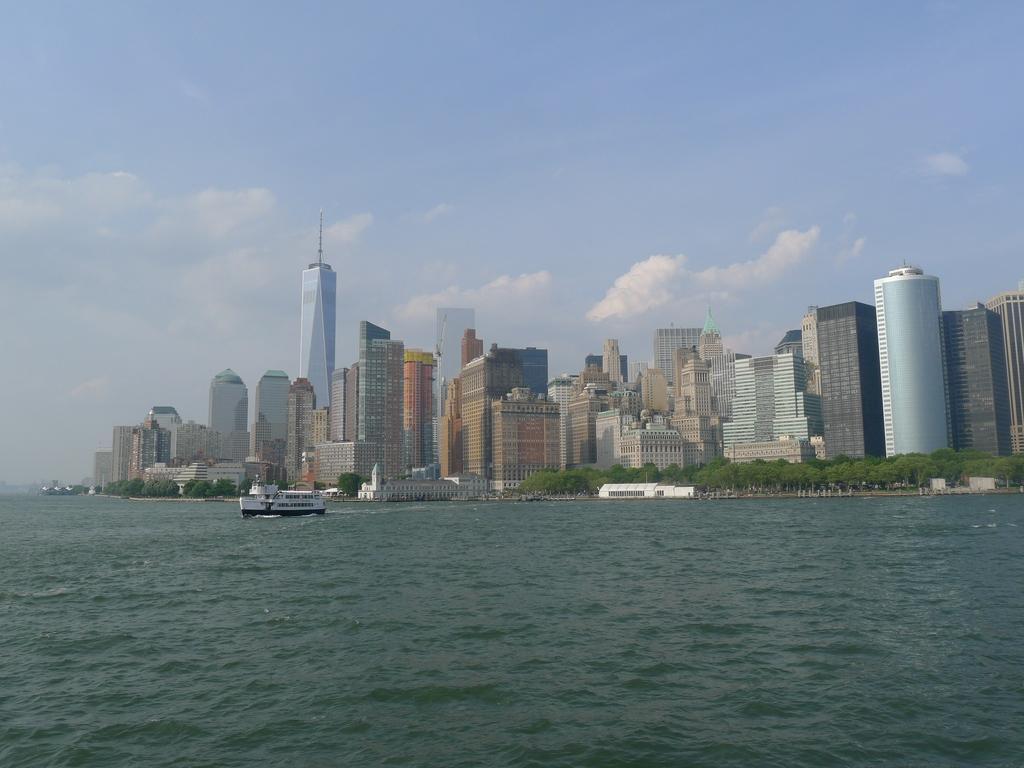Can you describe this image briefly? In this image we can see a ship on the water. In the background there are buildings, trees and clouds in the sky. 